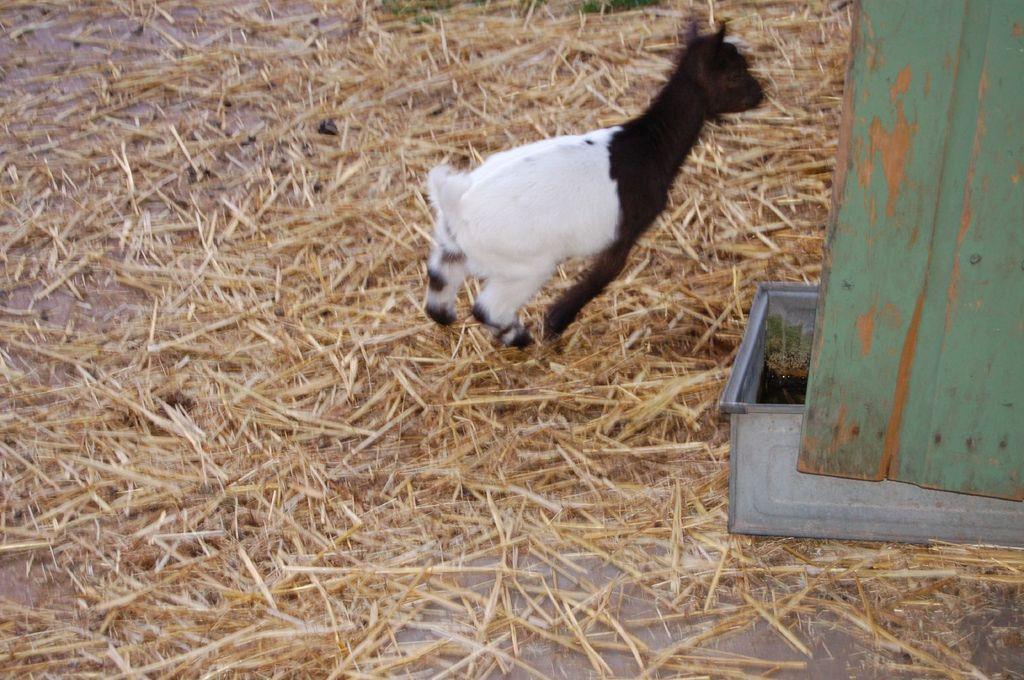Describe this image in one or two sentences. In this image we can see a goat on the dried grass. On the right side of the image we can see a container with water placed on the ground and a wooden board. 